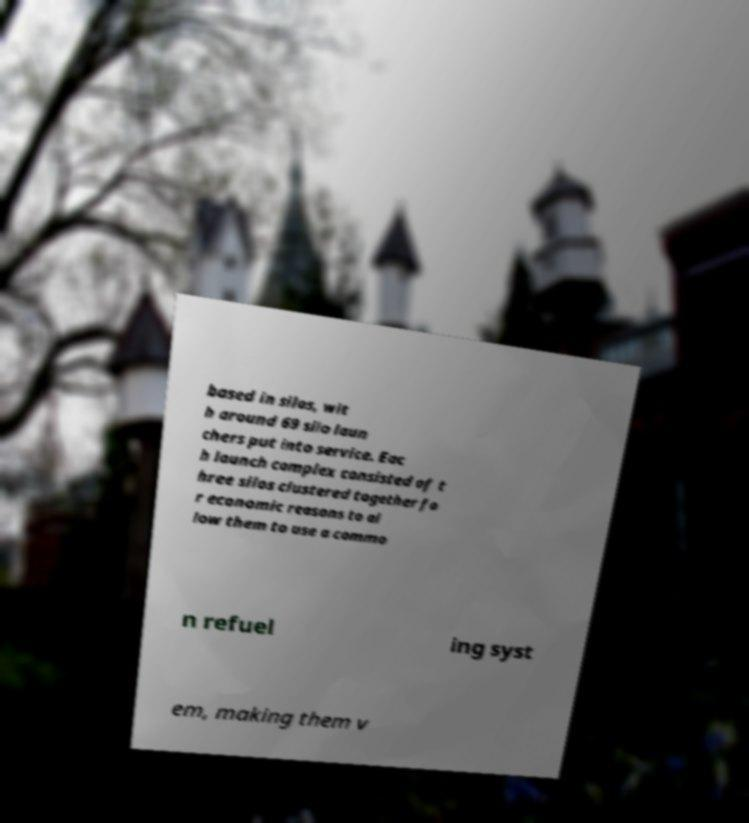Could you extract and type out the text from this image? based in silos, wit h around 69 silo laun chers put into service. Eac h launch complex consisted of t hree silos clustered together fo r economic reasons to al low them to use a commo n refuel ing syst em, making them v 